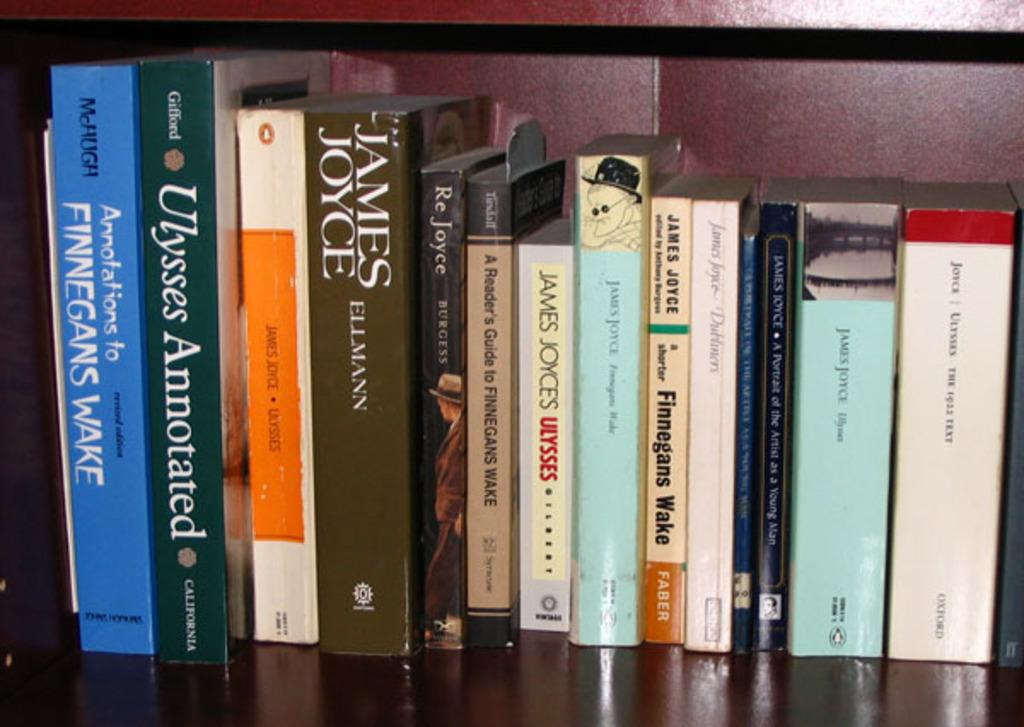<image>
Share a concise interpretation of the image provided. a row of books with one called ulysses by james joyces 